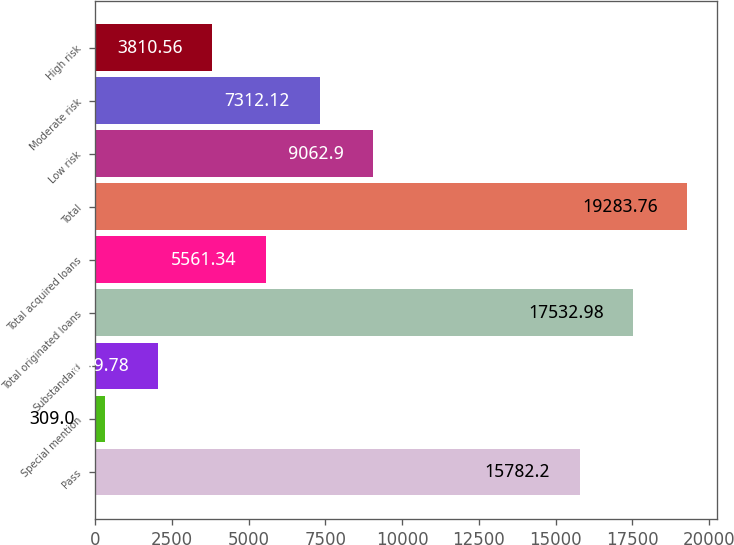<chart> <loc_0><loc_0><loc_500><loc_500><bar_chart><fcel>Pass<fcel>Special mention<fcel>Substandard<fcel>Total originated loans<fcel>Total acquired loans<fcel>Total<fcel>Low risk<fcel>Moderate risk<fcel>High risk<nl><fcel>15782.2<fcel>309<fcel>2059.78<fcel>17533<fcel>5561.34<fcel>19283.8<fcel>9062.9<fcel>7312.12<fcel>3810.56<nl></chart> 